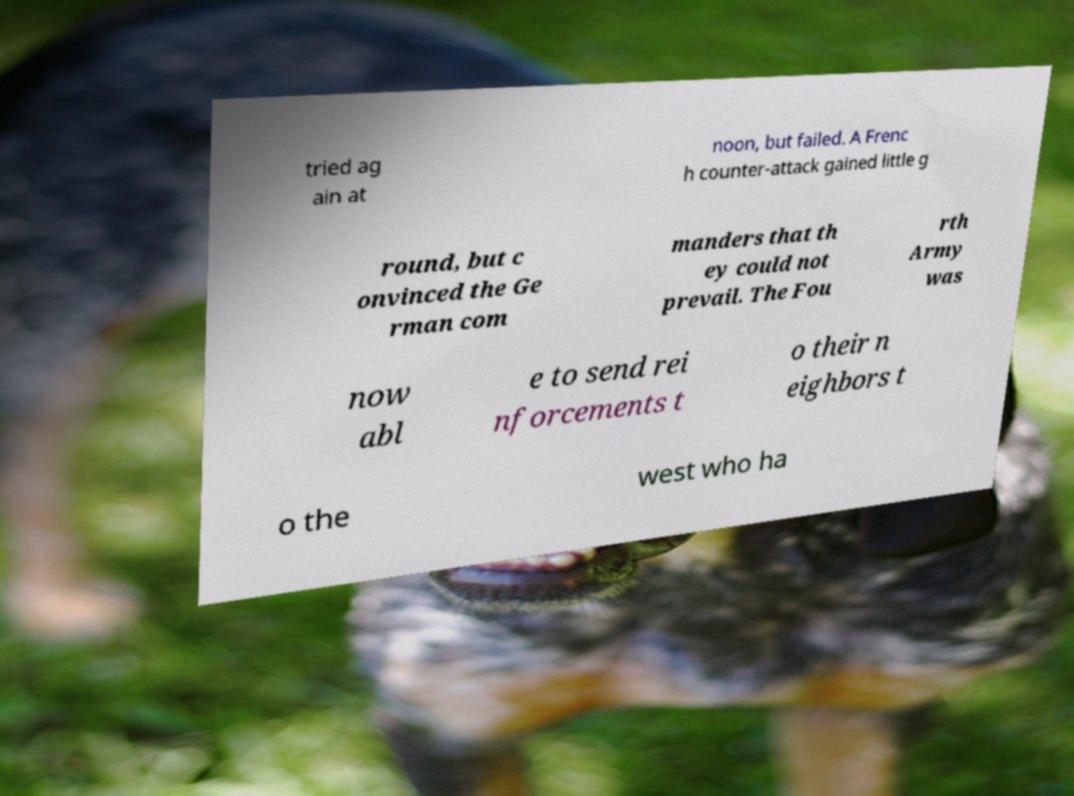Could you extract and type out the text from this image? tried ag ain at noon, but failed. A Frenc h counter-attack gained little g round, but c onvinced the Ge rman com manders that th ey could not prevail. The Fou rth Army was now abl e to send rei nforcements t o their n eighbors t o the west who ha 